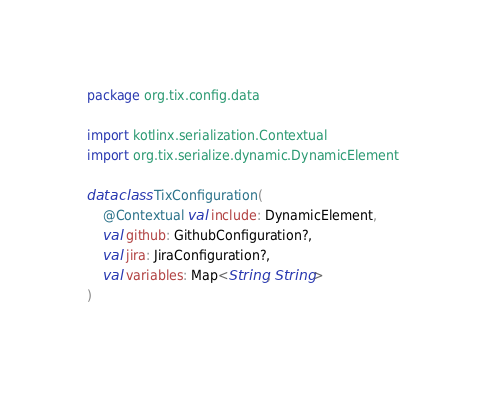<code> <loc_0><loc_0><loc_500><loc_500><_Kotlin_>package org.tix.config.data

import kotlinx.serialization.Contextual
import org.tix.serialize.dynamic.DynamicElement

data class TixConfiguration(
    @Contextual val include: DynamicElement,
    val github: GithubConfiguration?,
    val jira: JiraConfiguration?,
    val variables: Map<String, String>
)</code> 